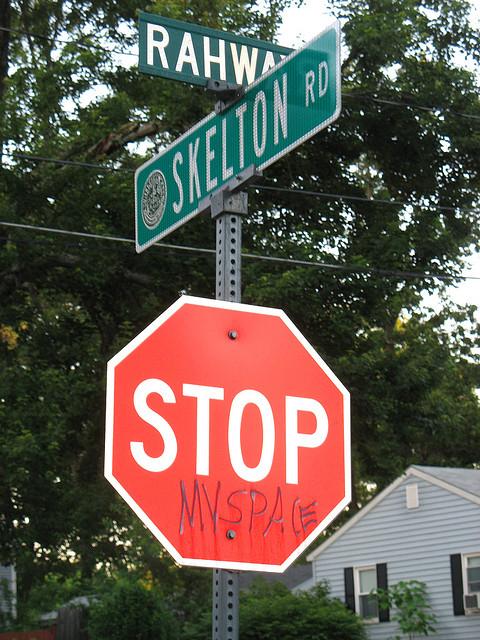What road is this?
Quick response, please. Skeleton. What word is above "stop"?
Quick response, please. Skeleton. Where is the graffiti?
Concise answer only. On stop sign. Is this in a city?
Write a very short answer. Yes. What does the graffiti say?
Short answer required. Myspace. 